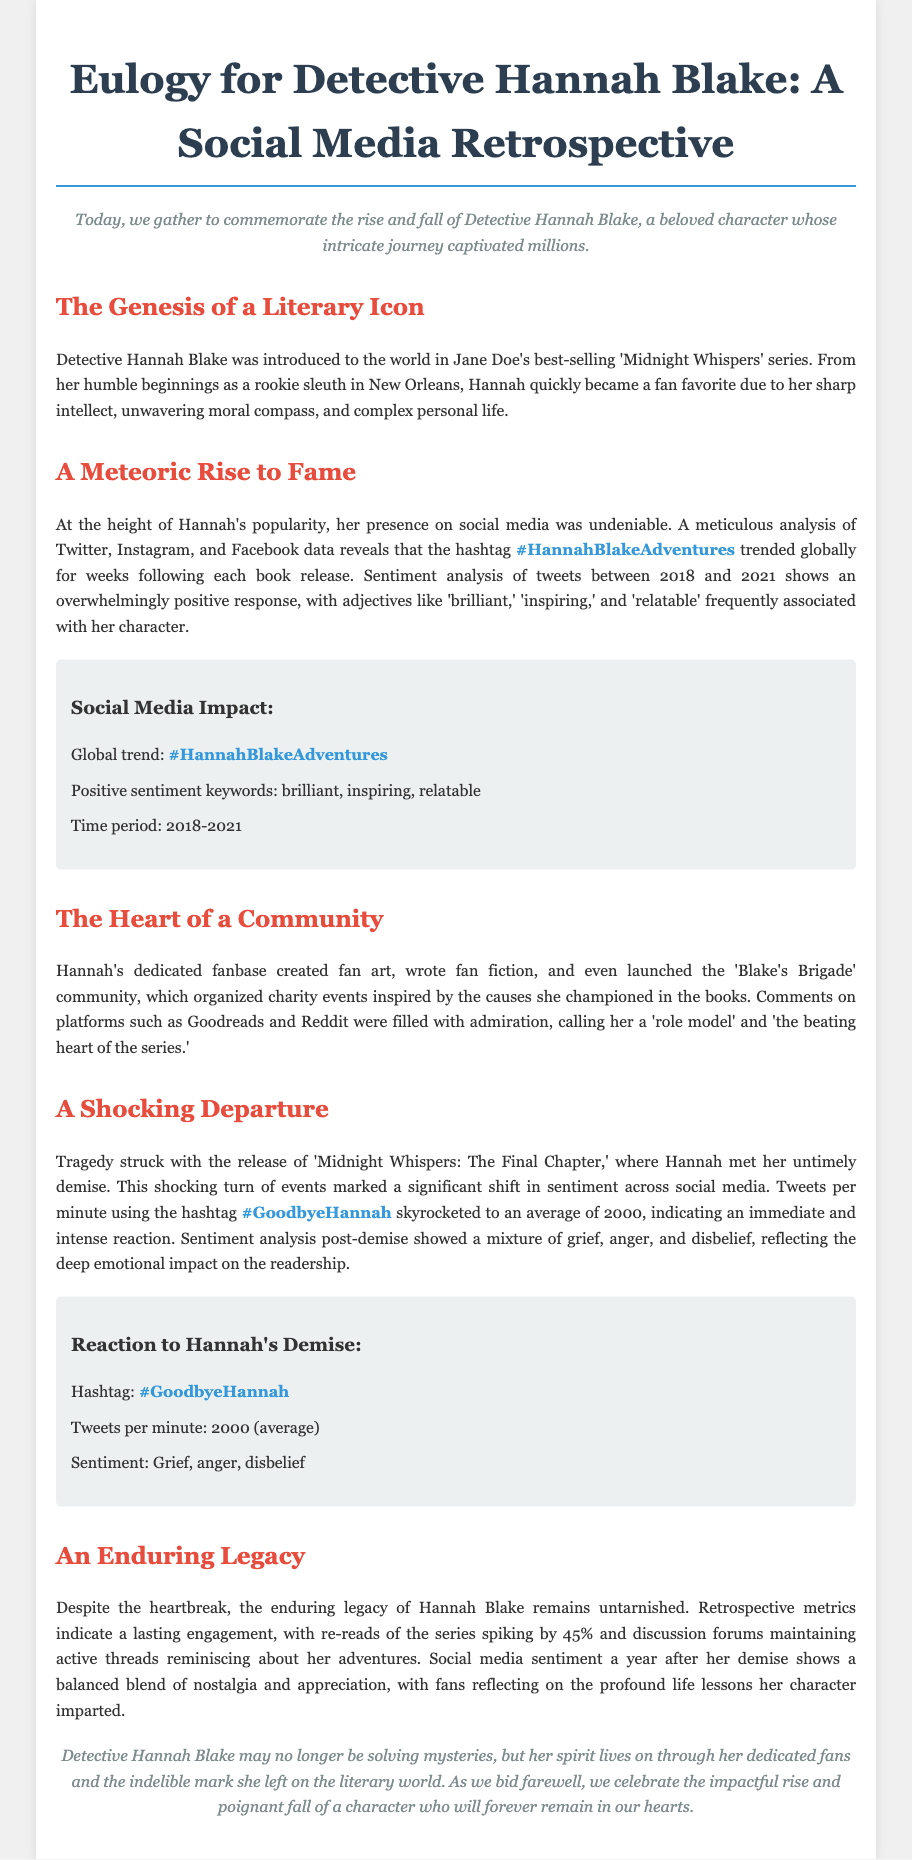What year was Detective Hannah Blake introduced? The document states that she was introduced in Jane Doe's best-selling series, which is unspecified but occurs before 2018, marking the start of her social media presence.
Answer: 2018 What trend did the hashtag #HannahBlakeAdventures reach? The document notes that the hashtag trended globally, indicated by the usage statistics following book releases.
Answer: Globally What emotion predominated in social media responses after Hannah's demise? The eulogy describes the sentiment following her death as including grief, anger, and disbelief from her fanbase.
Answer: Grief How much did re-reads of the series spike post-demise? The document specifies that re-reads increased significantly as fans turned back to the books after her death.
Answer: 45% What community was created around Detective Hannah Blake? The fans formed a community that supported various causes she was associated with, leading to events and celebrations of her character.
Answer: Blake's Brigade What was the average tweets per minute during the reaction to Hannah's demise? A specific metric provided indicates how frequently fans expressed their feelings through social media at that time.
Answer: 2000 What type of character was Detective Hannah Blake described as? The eulogy highlights several traits that contributed to her popularity among readers and followers, showcasing her qualities.
Answer: Brilliant What genre does the series featuring Hannah Blake belong to? The genre is a critical factor in understanding the narrative and the emotional connection readers had with the character.
Answer: Mystery thriller 